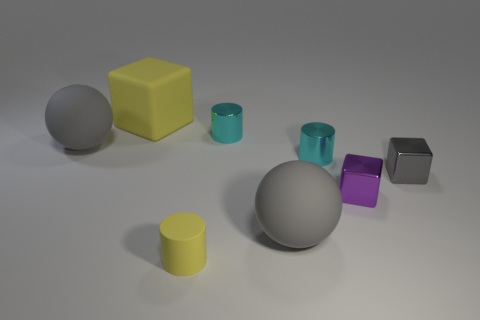Add 2 tiny metal things. How many objects exist? 10 Subtract all cylinders. How many objects are left? 5 Subtract 1 yellow cubes. How many objects are left? 7 Subtract all large cyan objects. Subtract all cyan cylinders. How many objects are left? 6 Add 3 tiny shiny cylinders. How many tiny shiny cylinders are left? 5 Add 7 cyan cylinders. How many cyan cylinders exist? 9 